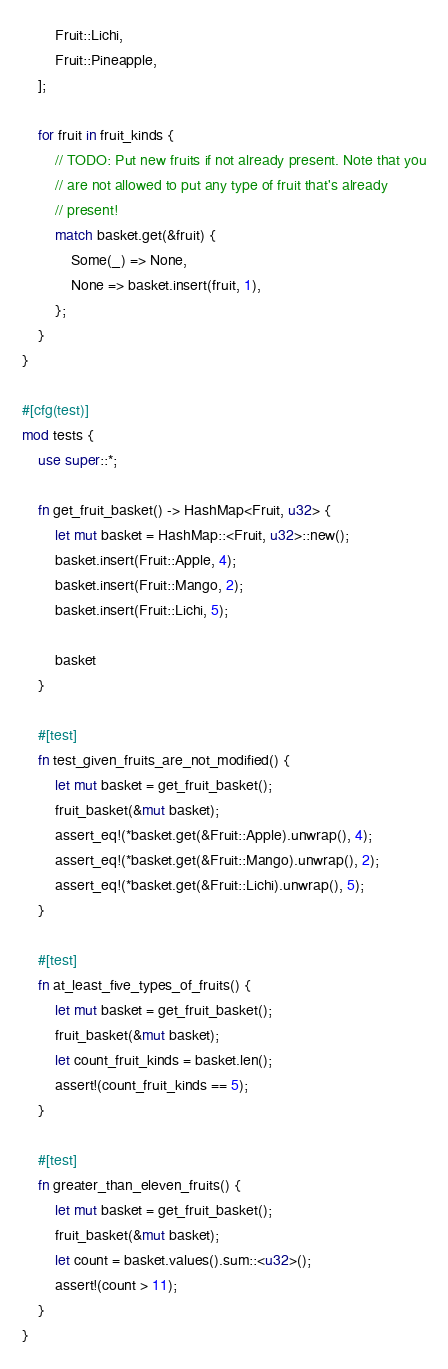Convert code to text. <code><loc_0><loc_0><loc_500><loc_500><_Rust_>        Fruit::Lichi,
        Fruit::Pineapple,
    ];

    for fruit in fruit_kinds {
        // TODO: Put new fruits if not already present. Note that you
        // are not allowed to put any type of fruit that's already
        // present!
        match basket.get(&fruit) {
            Some(_) => None,
            None => basket.insert(fruit, 1),
        };
    }
}

#[cfg(test)]
mod tests {
    use super::*;

    fn get_fruit_basket() -> HashMap<Fruit, u32> {
        let mut basket = HashMap::<Fruit, u32>::new();
        basket.insert(Fruit::Apple, 4);
        basket.insert(Fruit::Mango, 2);
        basket.insert(Fruit::Lichi, 5);

        basket
    }

    #[test]
    fn test_given_fruits_are_not_modified() {
        let mut basket = get_fruit_basket();
        fruit_basket(&mut basket);
        assert_eq!(*basket.get(&Fruit::Apple).unwrap(), 4);
        assert_eq!(*basket.get(&Fruit::Mango).unwrap(), 2);
        assert_eq!(*basket.get(&Fruit::Lichi).unwrap(), 5);
    }

    #[test]
    fn at_least_five_types_of_fruits() {
        let mut basket = get_fruit_basket();
        fruit_basket(&mut basket);
        let count_fruit_kinds = basket.len();
        assert!(count_fruit_kinds == 5);
    }

    #[test]
    fn greater_than_eleven_fruits() {
        let mut basket = get_fruit_basket();
        fruit_basket(&mut basket);
        let count = basket.values().sum::<u32>();
        assert!(count > 11);
    }
}
</code> 